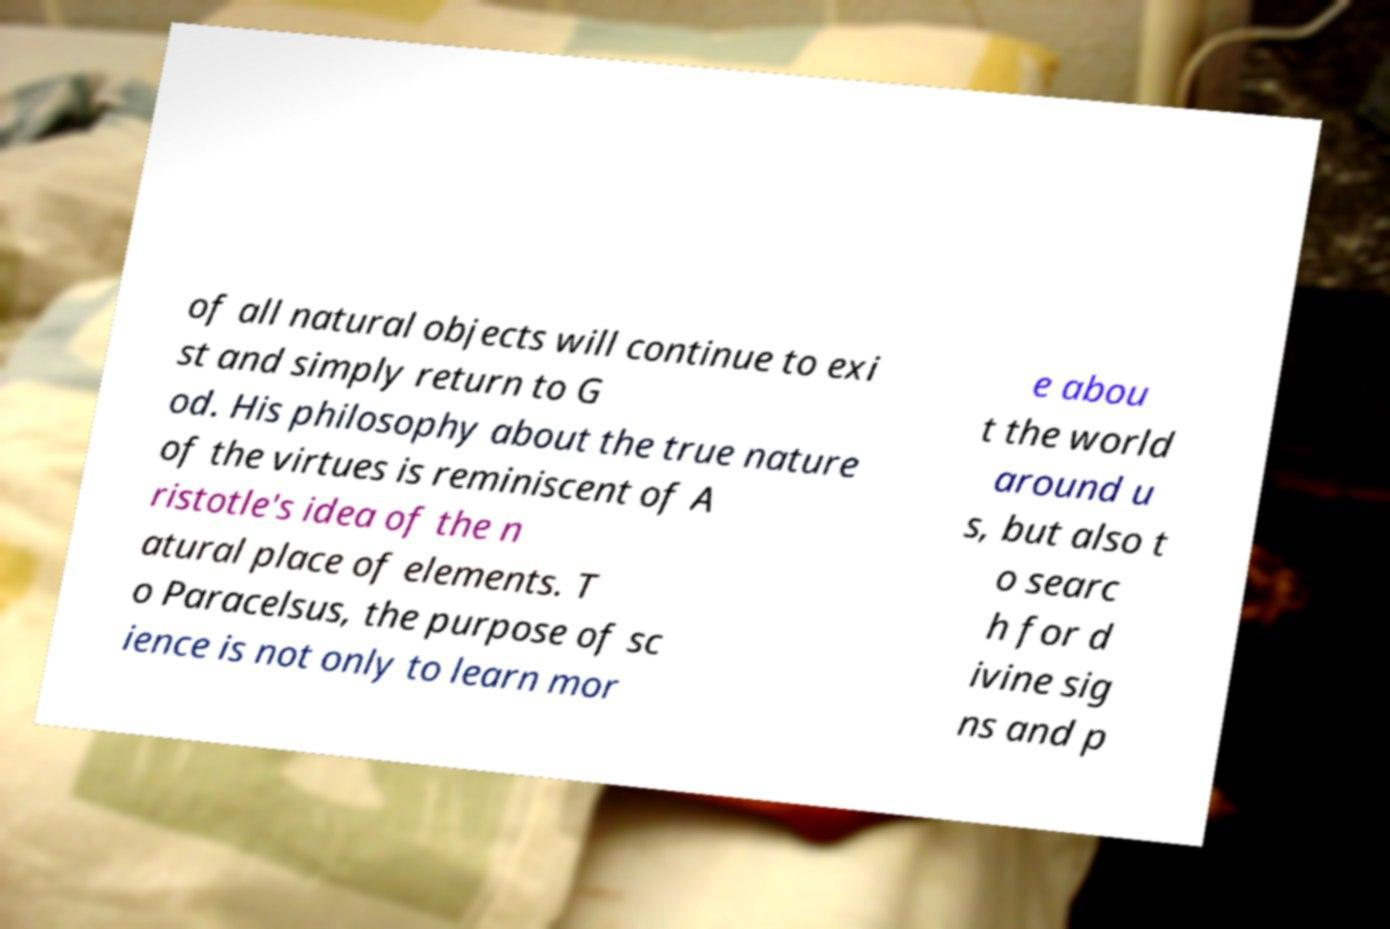Could you assist in decoding the text presented in this image and type it out clearly? of all natural objects will continue to exi st and simply return to G od. His philosophy about the true nature of the virtues is reminiscent of A ristotle's idea of the n atural place of elements. T o Paracelsus, the purpose of sc ience is not only to learn mor e abou t the world around u s, but also t o searc h for d ivine sig ns and p 